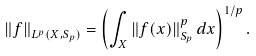Convert formula to latex. <formula><loc_0><loc_0><loc_500><loc_500>\left \| f \right \| _ { L ^ { p } ( X , S _ { p } ) } = \left ( \int _ { X } \left \| f ( x ) \right \| _ { S _ { p } } ^ { p } d x \right ) ^ { 1 / p } .</formula> 